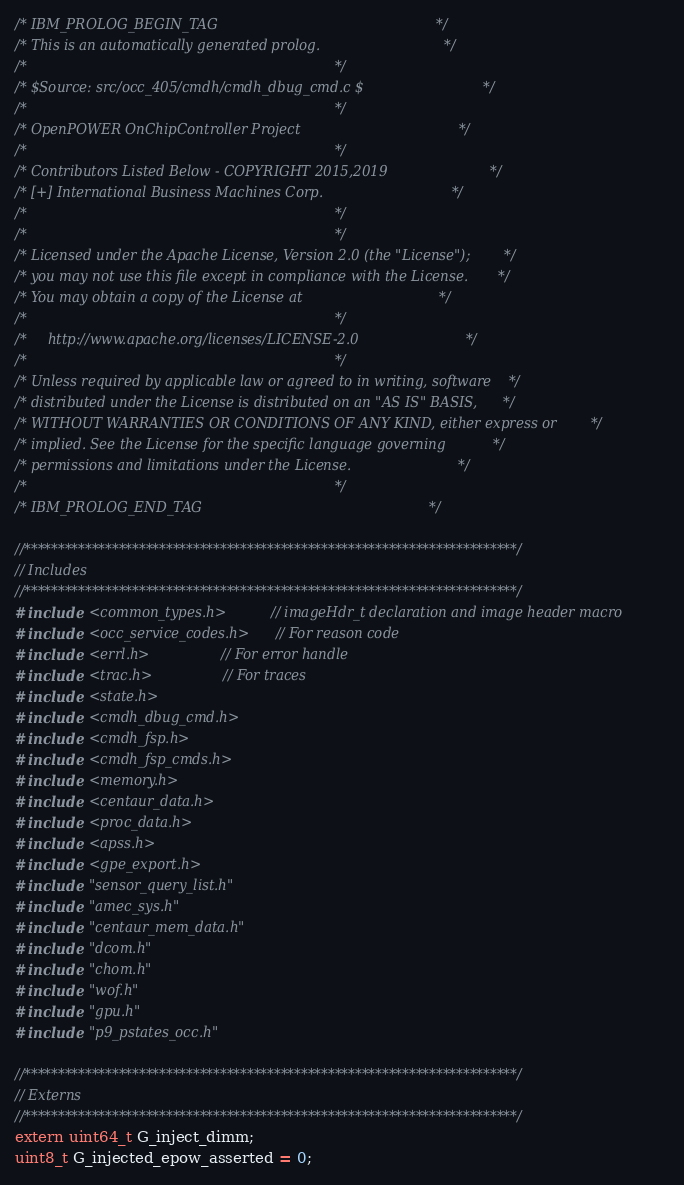<code> <loc_0><loc_0><loc_500><loc_500><_C_>/* IBM_PROLOG_BEGIN_TAG                                                   */
/* This is an automatically generated prolog.                             */
/*                                                                        */
/* $Source: src/occ_405/cmdh/cmdh_dbug_cmd.c $                            */
/*                                                                        */
/* OpenPOWER OnChipController Project                                     */
/*                                                                        */
/* Contributors Listed Below - COPYRIGHT 2015,2019                        */
/* [+] International Business Machines Corp.                              */
/*                                                                        */
/*                                                                        */
/* Licensed under the Apache License, Version 2.0 (the "License");        */
/* you may not use this file except in compliance with the License.       */
/* You may obtain a copy of the License at                                */
/*                                                                        */
/*     http://www.apache.org/licenses/LICENSE-2.0                         */
/*                                                                        */
/* Unless required by applicable law or agreed to in writing, software    */
/* distributed under the License is distributed on an "AS IS" BASIS,      */
/* WITHOUT WARRANTIES OR CONDITIONS OF ANY KIND, either express or        */
/* implied. See the License for the specific language governing           */
/* permissions and limitations under the License.                         */
/*                                                                        */
/* IBM_PROLOG_END_TAG                                                     */

//*************************************************************************/
// Includes
//*************************************************************************/
#include <common_types.h>       // imageHdr_t declaration and image header macro
#include <occ_service_codes.h>  // For reason code
#include <errl.h>               // For error handle
#include <trac.h>               // For traces
#include <state.h>
#include <cmdh_dbug_cmd.h>
#include <cmdh_fsp.h>
#include <cmdh_fsp_cmds.h>
#include <memory.h>
#include <centaur_data.h>
#include <proc_data.h>
#include <apss.h>
#include <gpe_export.h>
#include "sensor_query_list.h"
#include "amec_sys.h"
#include "centaur_mem_data.h"
#include "dcom.h"
#include "chom.h"
#include "wof.h"
#include "gpu.h"
#include "p9_pstates_occ.h"

//*************************************************************************/
// Externs
//*************************************************************************/
extern uint64_t G_inject_dimm;
uint8_t G_injected_epow_asserted = 0;</code> 